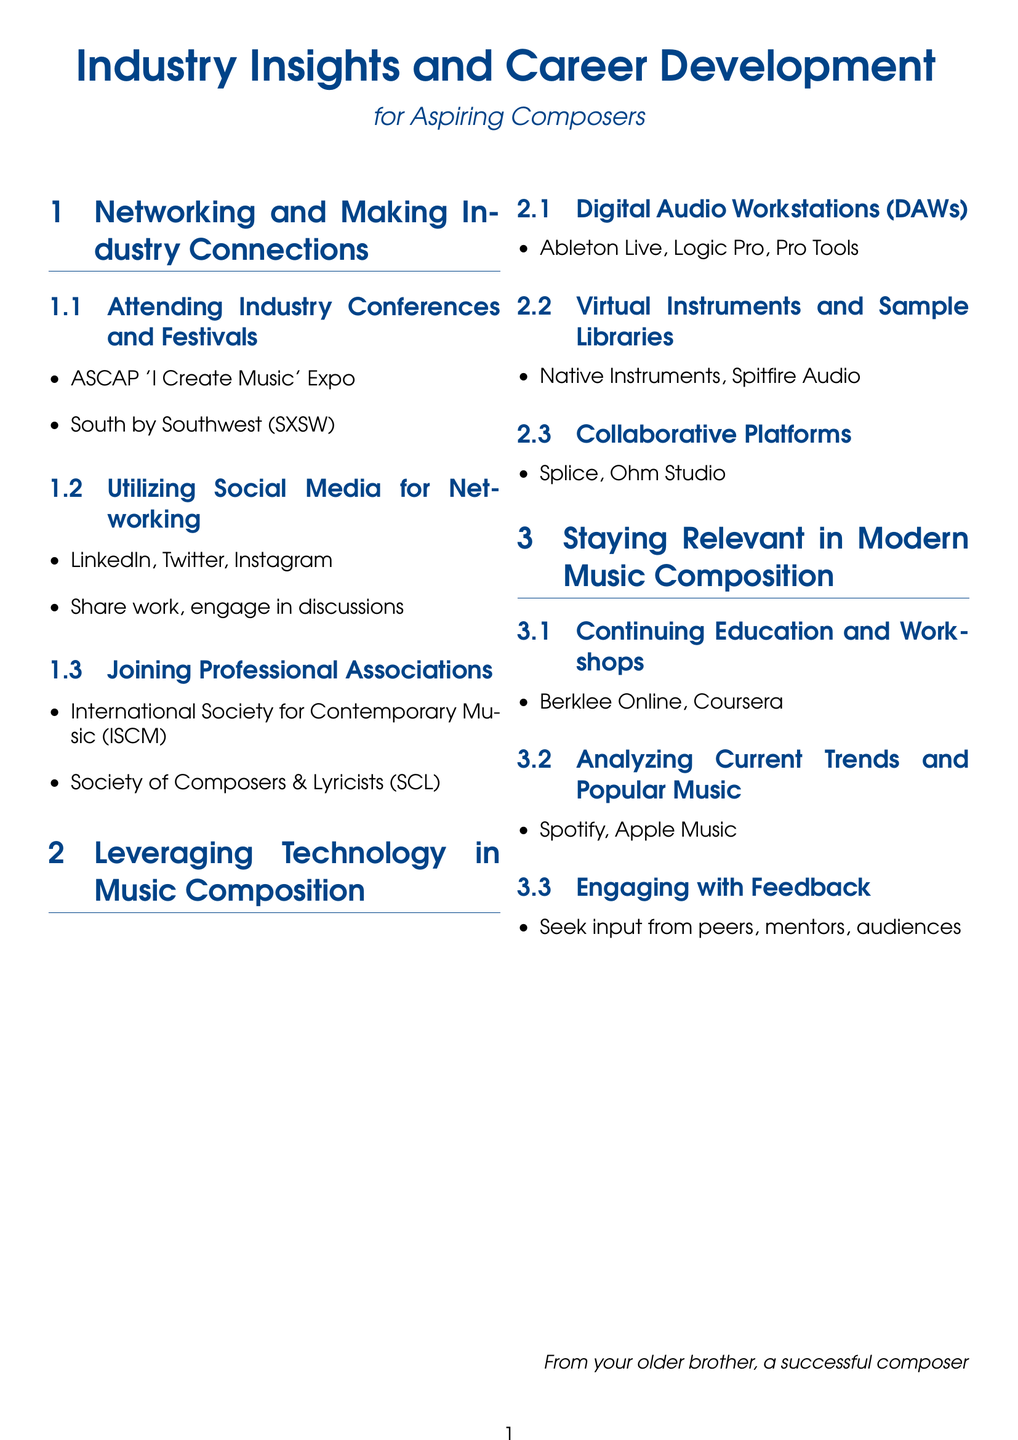What is the name of an industry conference listed? The document mentions specific industry conferences, one of which is ASCAP 'I Create Music' Expo.
Answer: ASCAP 'I Create Music' Expo Which social media platforms are suggested for networking? The document lists several social media platforms helpful for networking, including LinkedIn, Twitter, and Instagram.
Answer: LinkedIn, Twitter, Instagram What is one example of a Digital Audio Workstation mentioned? The document lists examples of Digital Audio Workstations, including Ableton Live.
Answer: Ableton Live Name a collaborative platform for composers. The document highlights platforms for collaboration, one of which is Splice.
Answer: Splice What educational resource is suggested for continuing education? The document recommends Berklee Online as a continuing education resource.
Answer: Berklee Online Which type of feedback should composers seek? The document emphasizes the importance of engaging with feedback from peers, mentors, and audiences.
Answer: Peers, mentors, audiences What is one of the professional associations mentioned? The document refers to specific professional associations, including the International Society for Contemporary Music (ISCM).
Answer: International Society for Contemporary Music (ISCM) What is indicated as a trend analysis resource? The document mentions Spotify and Apple Music as platforms for analyzing current trends and popular music.
Answer: Spotify, Apple Music What type of instruments are suggested for music composition? In the document, virtual instruments and sample libraries such as Native Instruments are recommended.
Answer: Native Instruments 